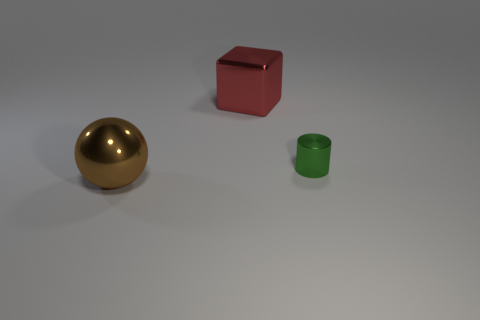How many purple things are large metallic balls or tiny metallic objects?
Keep it short and to the point. 0. How many big red metallic things are the same shape as the tiny green shiny thing?
Ensure brevity in your answer.  0. The red metallic object that is the same size as the brown ball is what shape?
Keep it short and to the point. Cube. There is a brown thing; are there any brown metal objects in front of it?
Keep it short and to the point. No. There is a big thing that is to the right of the big brown metallic ball; are there any small green objects behind it?
Provide a succinct answer. No. Are there fewer red blocks on the left side of the big red metallic block than large red shiny objects that are right of the metallic cylinder?
Give a very brief answer. No. Is there anything else that is the same size as the green cylinder?
Keep it short and to the point. No. The small thing is what shape?
Your answer should be compact. Cylinder. What is the object that is left of the red metallic thing made of?
Keep it short and to the point. Metal. How big is the thing on the right side of the big shiny thing that is behind the thing in front of the tiny green object?
Ensure brevity in your answer.  Small. 